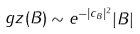Convert formula to latex. <formula><loc_0><loc_0><loc_500><loc_500>\ g z ( B ) \sim e ^ { - | c _ { B } | ^ { 2 } } | B |</formula> 